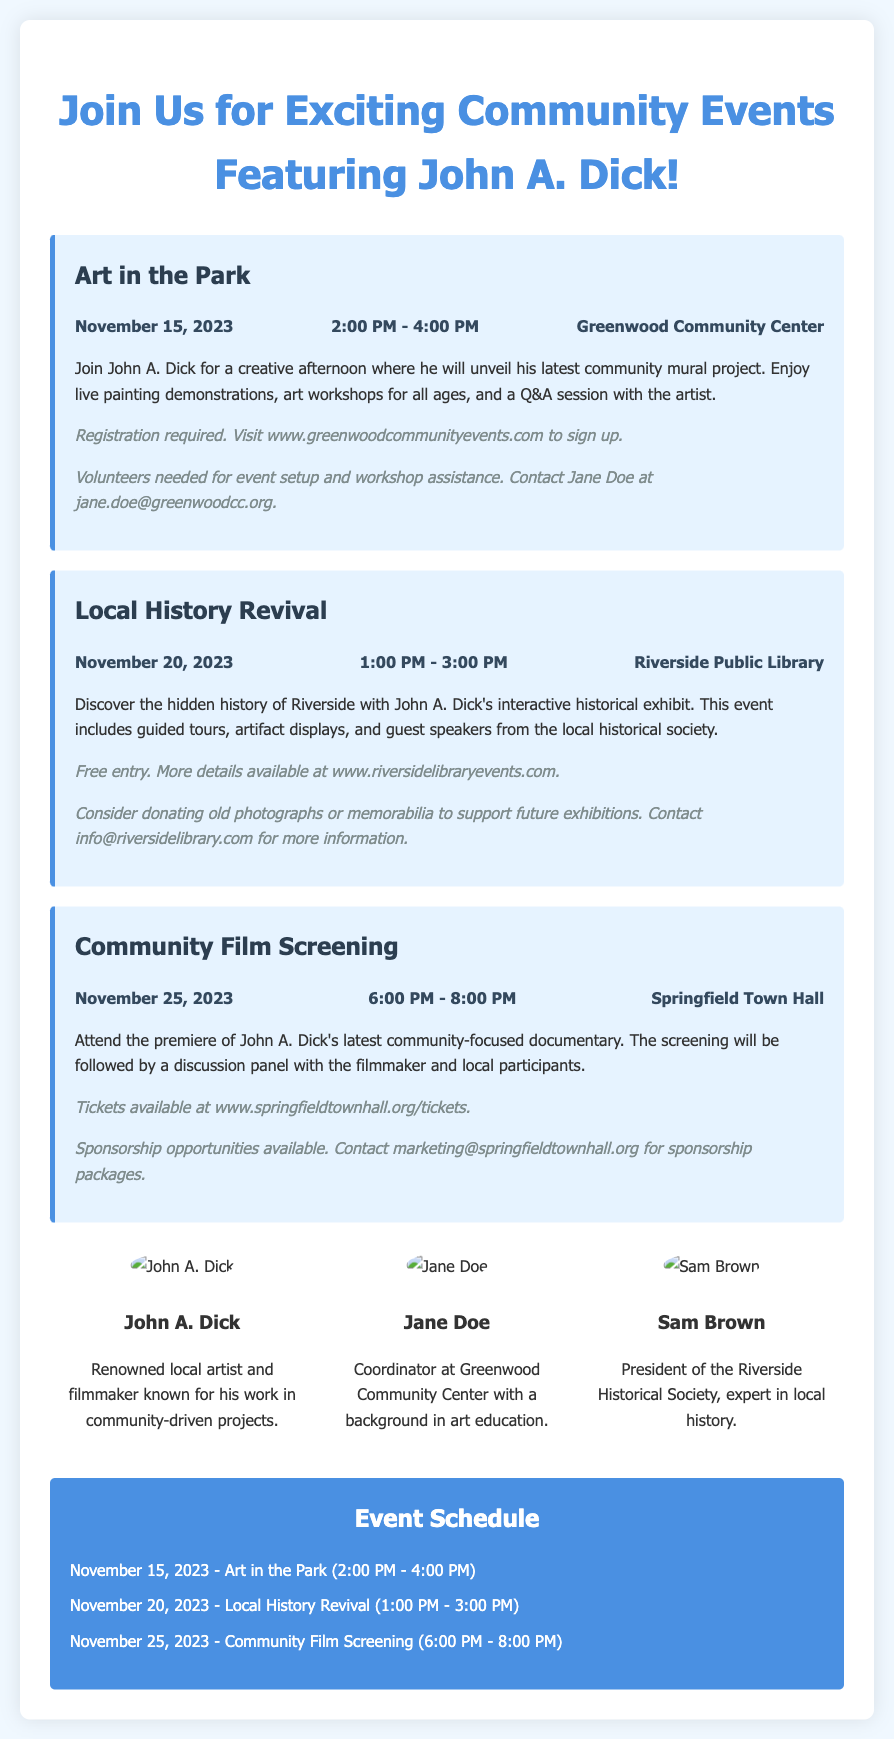what is the date of the "Art in the Park" event? The event is scheduled for November 15, 2023, as mentioned in the event details.
Answer: November 15, 2023 where will the "Local History Revival" take place? The location is specified in the event details, which states Riverside Public Library.
Answer: Riverside Public Library how long is the "Community Film Screening"? The time given for the screening is from 6:00 PM to 8:00 PM, making it two hours long.
Answer: 2 hours who is the coordinator at the Greenwood Community Center? Jane Doe is mentioned in the profiles as the coordinator at Greenwood Community Center.
Answer: Jane Doe what type of event is "Art in the Park"? The event is described as a creative afternoon focused on art demonstrations and workshops.
Answer: Creative afternoon how many events are listed in the schedule? The schedule includes three distinct events as detailed in the document.
Answer: 3 what is required to participate in the "Art in the Park" event? The flyer mentions that registration is required to participate in this event.
Answer: Registration required what color represents the event sections in the flyer? The background color of the events is described as light blue in the document's formatting.
Answer: Light blue what is the name of the local historical society president? Sam Brown is identified in the profiles as the president of the Riverside Historical Society.
Answer: Sam Brown 